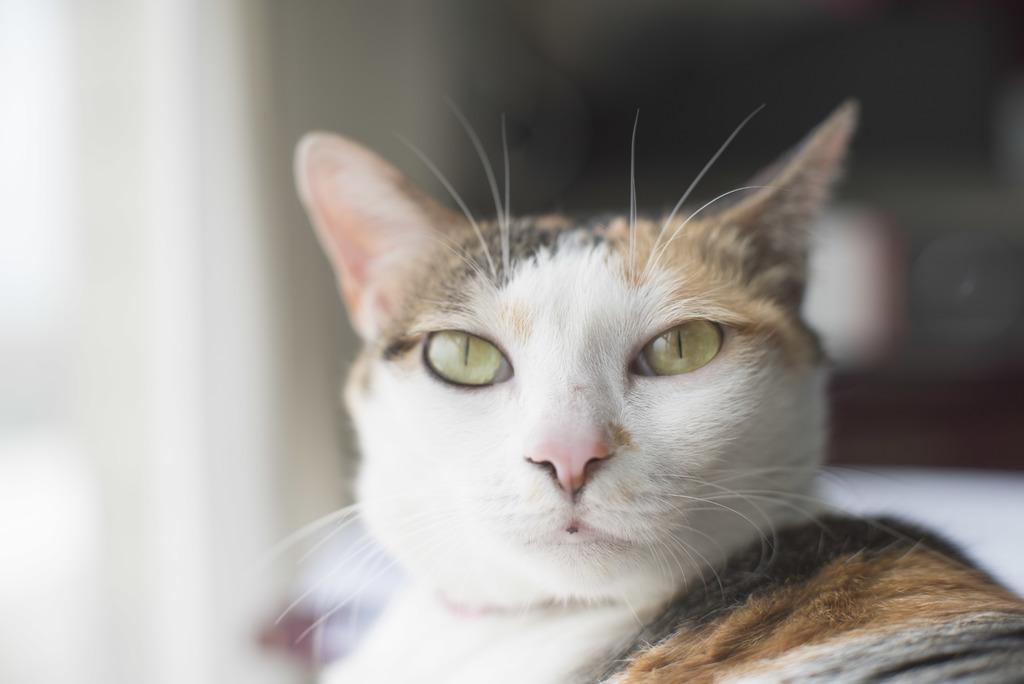What type of animal is in the image? There is a cat in the image. Can you describe the background of the image? The background of the image is blurry. What type of horn is visible on the cat in the image? There is no horn visible on the cat in the image. What is the cat's income in the image? The image does not provide information about the cat's income. 